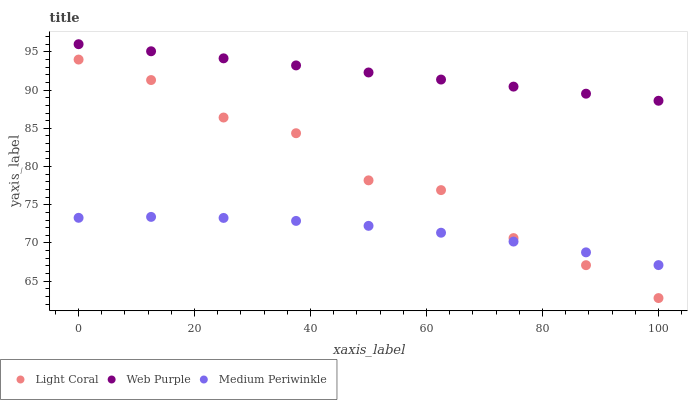Does Medium Periwinkle have the minimum area under the curve?
Answer yes or no. Yes. Does Web Purple have the maximum area under the curve?
Answer yes or no. Yes. Does Web Purple have the minimum area under the curve?
Answer yes or no. No. Does Medium Periwinkle have the maximum area under the curve?
Answer yes or no. No. Is Web Purple the smoothest?
Answer yes or no. Yes. Is Light Coral the roughest?
Answer yes or no. Yes. Is Medium Periwinkle the smoothest?
Answer yes or no. No. Is Medium Periwinkle the roughest?
Answer yes or no. No. Does Light Coral have the lowest value?
Answer yes or no. Yes. Does Medium Periwinkle have the lowest value?
Answer yes or no. No. Does Web Purple have the highest value?
Answer yes or no. Yes. Does Medium Periwinkle have the highest value?
Answer yes or no. No. Is Light Coral less than Web Purple?
Answer yes or no. Yes. Is Web Purple greater than Medium Periwinkle?
Answer yes or no. Yes. Does Medium Periwinkle intersect Light Coral?
Answer yes or no. Yes. Is Medium Periwinkle less than Light Coral?
Answer yes or no. No. Is Medium Periwinkle greater than Light Coral?
Answer yes or no. No. Does Light Coral intersect Web Purple?
Answer yes or no. No. 